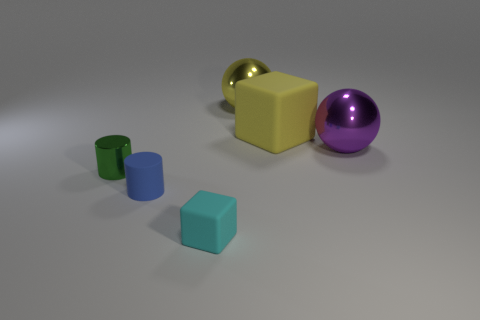What is the shape of the yellow shiny thing that is the same size as the purple ball?
Your response must be concise. Sphere. Is there a brown matte cylinder of the same size as the blue cylinder?
Give a very brief answer. No. What is the material of the blue cylinder that is the same size as the cyan matte thing?
Make the answer very short. Rubber. There is a matte cube that is behind the matte block that is in front of the large rubber block; how big is it?
Offer a terse response. Large. There is a matte object to the left of the cyan rubber cube; is it the same size as the large yellow cube?
Keep it short and to the point. No. Is the number of small metallic cylinders that are in front of the metallic cylinder greater than the number of small metallic cylinders that are in front of the cyan thing?
Make the answer very short. No. There is a thing that is both on the left side of the large yellow block and on the right side of the tiny cyan object; what is its shape?
Provide a short and direct response. Sphere. What is the shape of the small rubber thing on the left side of the cyan thing?
Your answer should be very brief. Cylinder. There is a shiny thing left of the matte thing that is to the left of the block that is in front of the yellow rubber block; what is its size?
Your answer should be very brief. Small. Is the shape of the small blue matte object the same as the small cyan rubber thing?
Ensure brevity in your answer.  No. 